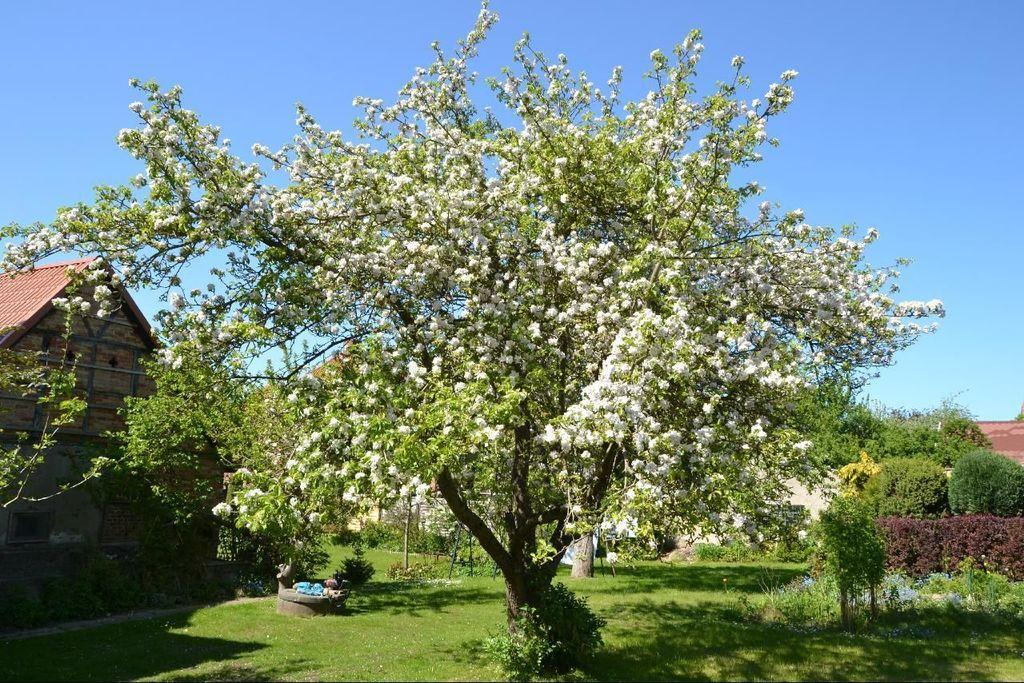What type of structure is visible in the image? There is a house in the image. What type of vegetation can be seen in the image? There are trees, plants, and flowers in the image. What type of event is taking place in the image, and who is the judge presiding over it? There is no event or judge present in the image; it features a house, trees, plants, and flowers. Can you see a badge on any of the plants in the image? There are no badges present on the plants or any other elements in the image. 